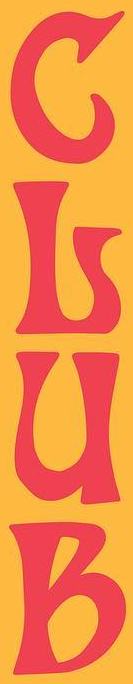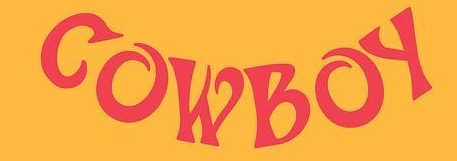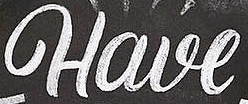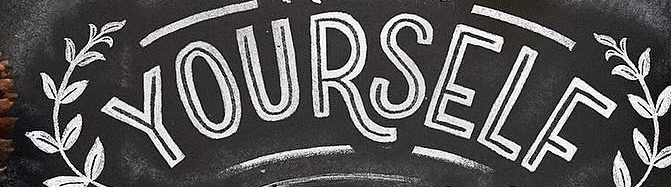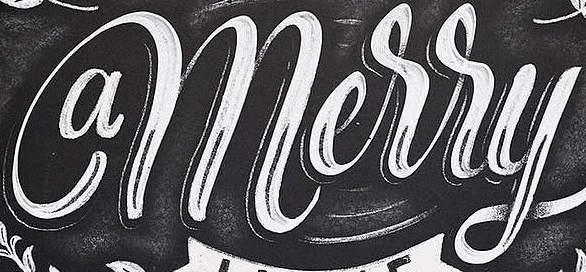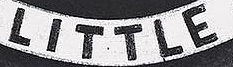Transcribe the words shown in these images in order, separated by a semicolon. GLUB; COWBOY; Have; YOURSELF; amerry; LITTLE 